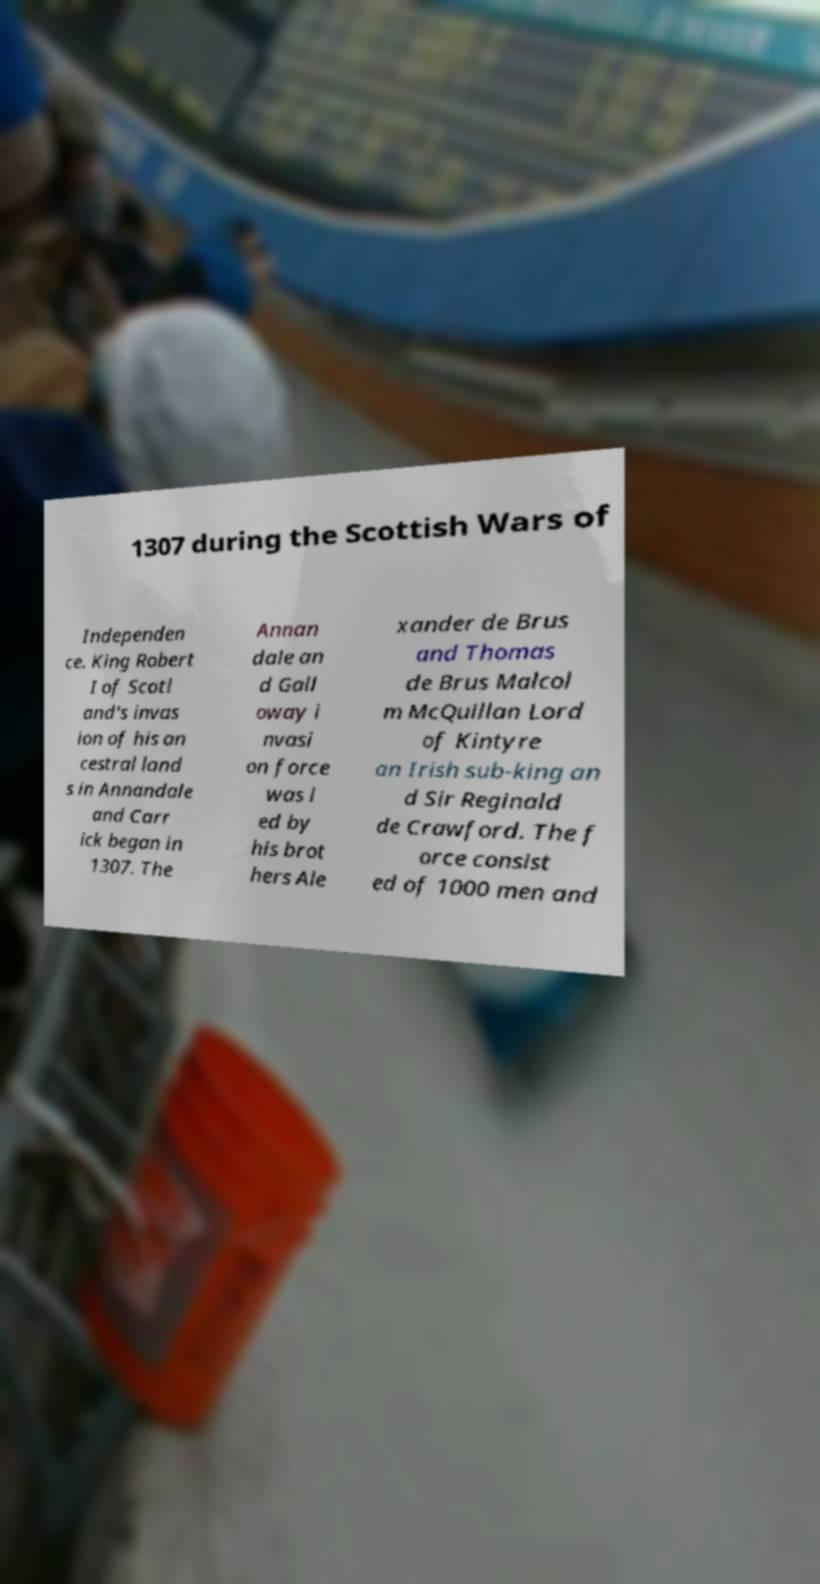Could you assist in decoding the text presented in this image and type it out clearly? 1307 during the Scottish Wars of Independen ce. King Robert I of Scotl and's invas ion of his an cestral land s in Annandale and Carr ick began in 1307. The Annan dale an d Gall oway i nvasi on force was l ed by his brot hers Ale xander de Brus and Thomas de Brus Malcol m McQuillan Lord of Kintyre an Irish sub-king an d Sir Reginald de Crawford. The f orce consist ed of 1000 men and 